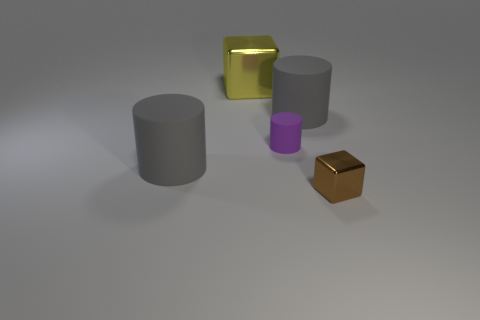Add 5 blocks. How many objects exist? 10 Subtract all cubes. How many objects are left? 3 Subtract all tiny metal objects. Subtract all gray rubber cylinders. How many objects are left? 2 Add 1 big yellow objects. How many big yellow objects are left? 2 Add 3 gray matte spheres. How many gray matte spheres exist? 3 Subtract 0 yellow balls. How many objects are left? 5 